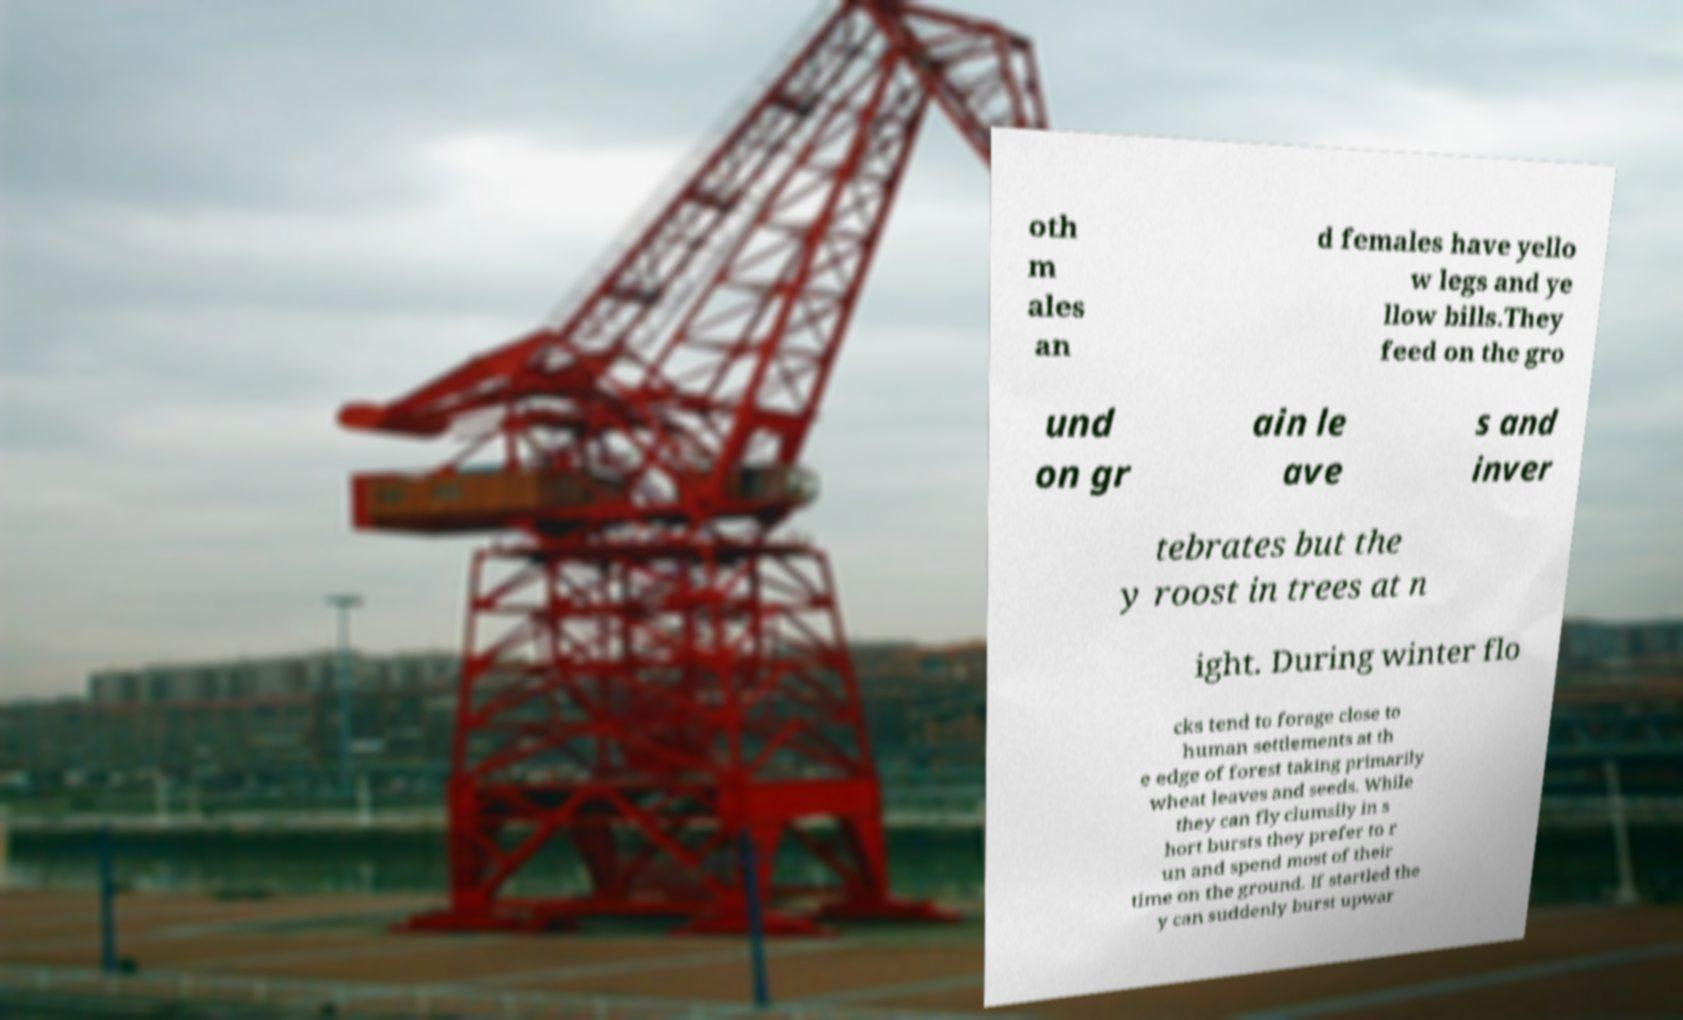I need the written content from this picture converted into text. Can you do that? oth m ales an d females have yello w legs and ye llow bills.They feed on the gro und on gr ain le ave s and inver tebrates but the y roost in trees at n ight. During winter flo cks tend to forage close to human settlements at th e edge of forest taking primarily wheat leaves and seeds. While they can fly clumsily in s hort bursts they prefer to r un and spend most of their time on the ground. If startled the y can suddenly burst upwar 